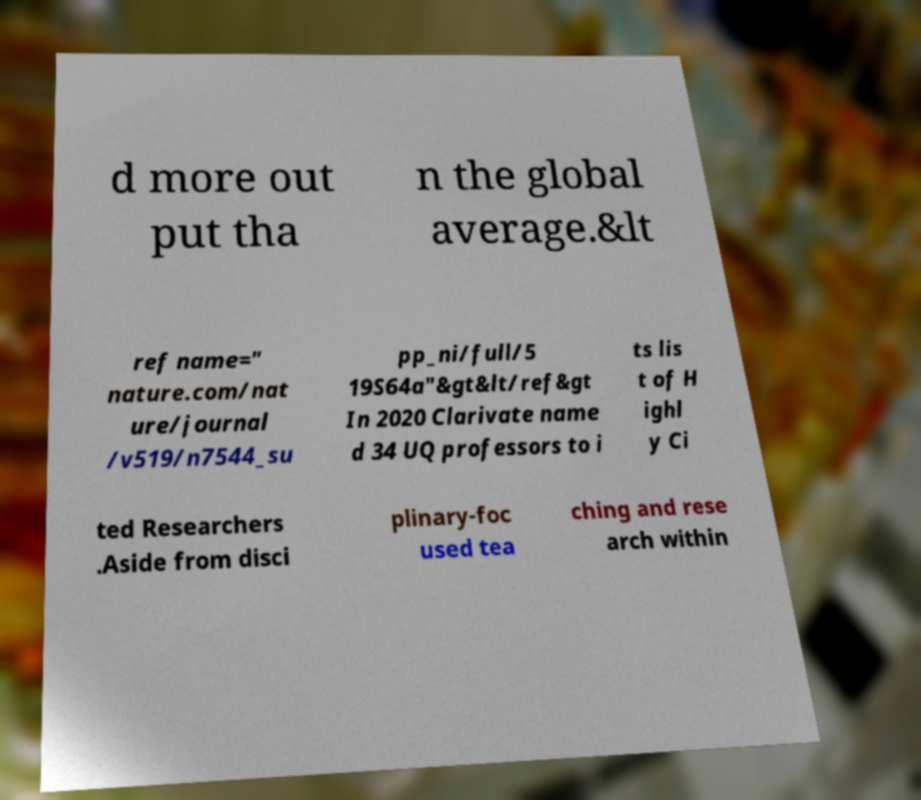I need the written content from this picture converted into text. Can you do that? d more out put tha n the global average.&lt ref name=" nature.com/nat ure/journal /v519/n7544_su pp_ni/full/5 19S64a"&gt&lt/ref&gt In 2020 Clarivate name d 34 UQ professors to i ts lis t of H ighl y Ci ted Researchers .Aside from disci plinary-foc used tea ching and rese arch within 